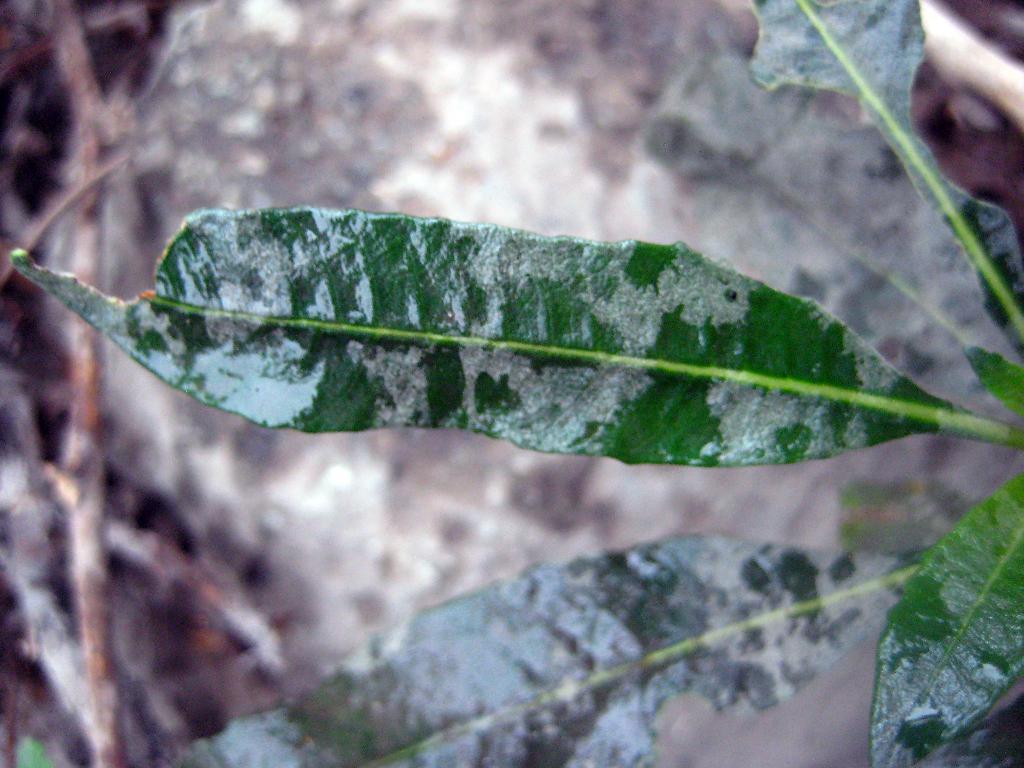In one or two sentences, can you explain what this image depicts? In this image, we can see leaves which are green in color and the background is blurred. 